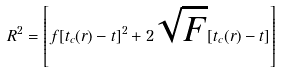<formula> <loc_0><loc_0><loc_500><loc_500>R ^ { 2 } = \left [ f [ t _ { c } ( r ) - t ] ^ { 2 } + 2 \sqrt { F } [ t _ { c } ( r ) - t ] \right ]</formula> 